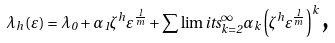Convert formula to latex. <formula><loc_0><loc_0><loc_500><loc_500>\lambda _ { h } \left ( \varepsilon \right ) = \lambda _ { 0 } + \alpha _ { 1 } \zeta ^ { h } \varepsilon ^ { \frac { 1 } { m } } + \sum \lim i t s _ { k = 2 } ^ { \infty } \alpha _ { k } \left ( \zeta ^ { h } \varepsilon ^ { \frac { 1 } { m } } \right ) ^ { k } \text {,}</formula> 